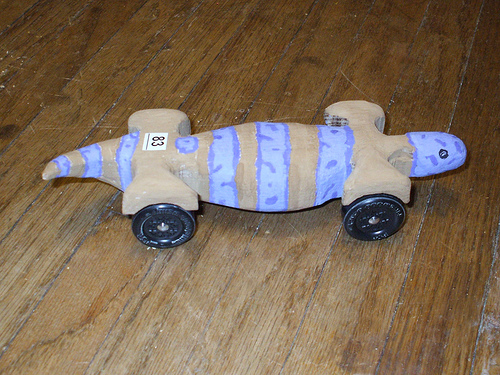<image>
Can you confirm if the model car is above the wood floor? No. The model car is not positioned above the wood floor. The vertical arrangement shows a different relationship. 